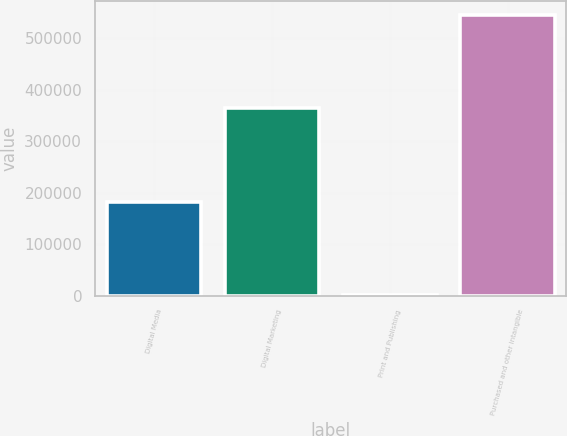Convert chart. <chart><loc_0><loc_0><loc_500><loc_500><bar_chart><fcel>Digital Media<fcel>Digital Marketing<fcel>Print and Publishing<fcel>Purchased and other intangible<nl><fcel>181888<fcel>363560<fcel>78<fcel>545526<nl></chart> 